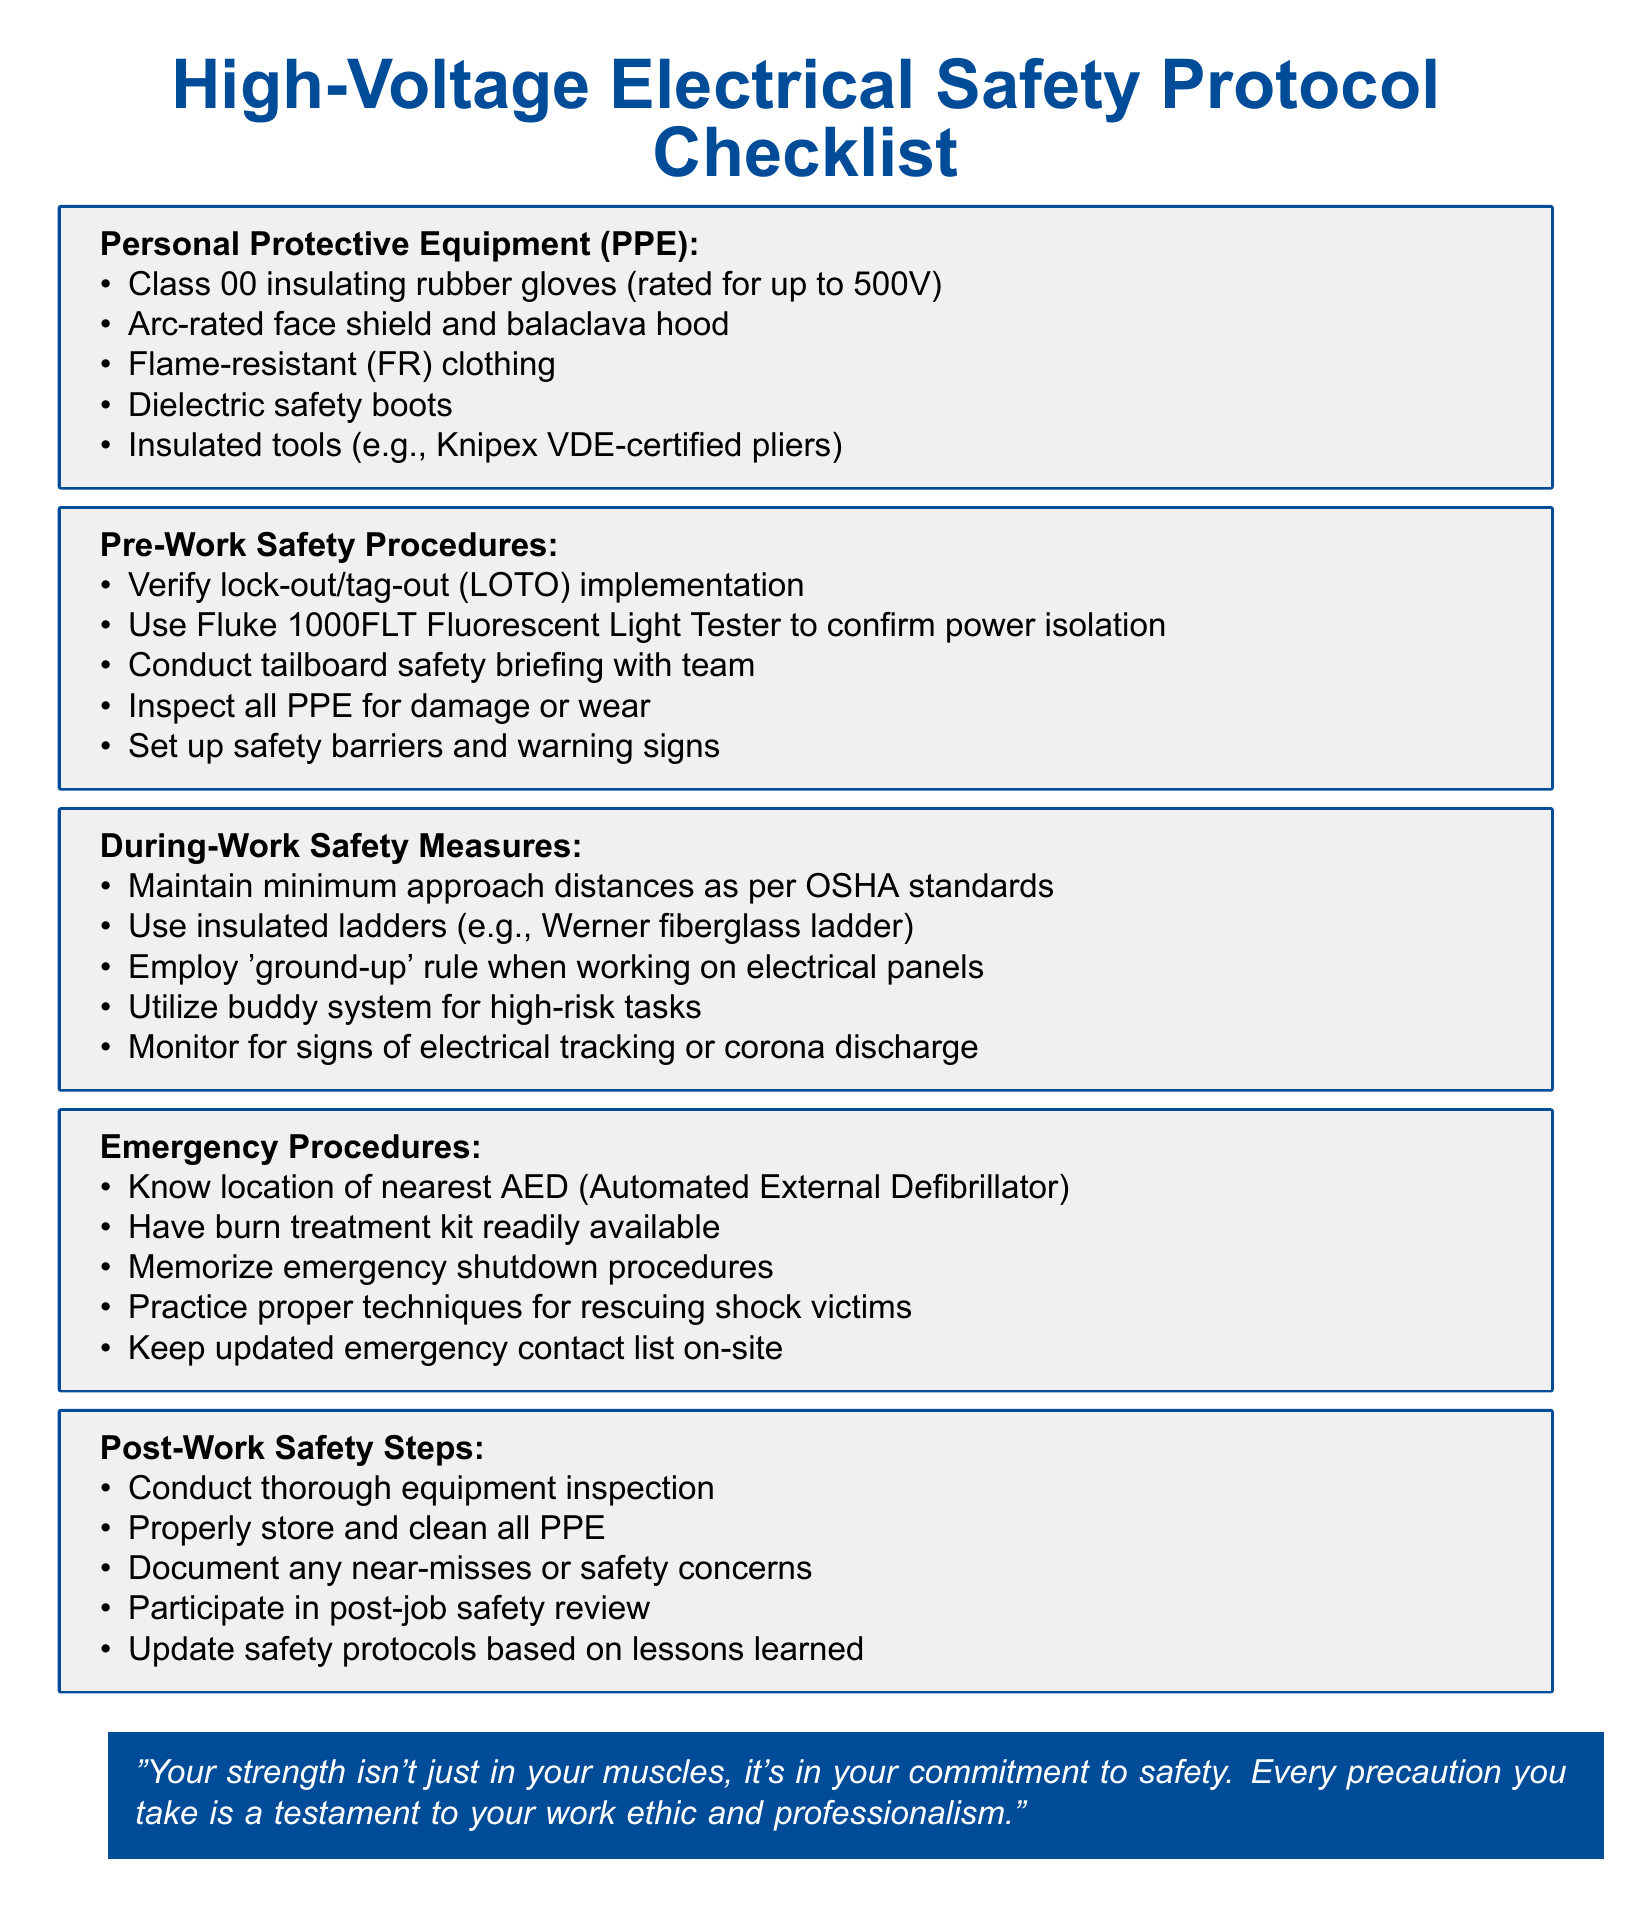What is the title of the checklist? The title of the checklist is specified at the beginning of the document.
Answer: High-Voltage Electrical Safety Protocol Checklist How many items are listed under Personal Protective Equipment (PPE)? The number of items in a specific section is clearly presented in the list format throughout the document.
Answer: 5 What type of gloves should be used? The specific type of gloves is mentioned in the PPE section for high-voltage safety.
Answer: Class 00 insulating rubber gloves What tools are recommended to confirm power isolation? The document explicitly states a specific tool for this purpose under pre-work safety procedures.
Answer: Fluke 1000FLT Fluorescent Light Tester What is the minimum distance to maintain according to OSHA standards? The minimum approach distance requirement is mentioned in the during-work safety measures.
Answer: Minimum approach distances What should be available for burn treatment? The item is specifically listed under emergency procedures as essential for addressing certain injuries.
Answer: Burn treatment kit What system should be utilized for high-risk tasks? The recommendation is made under during-work safety measures for increased safety during specific tasks.
Answer: Buddy system What should be documented after a job? This action is mentioned as an essential step in the post-work safety steps section of the checklist.
Answer: Near-misses or safety concerns In what situation should you memorize emergency shutdown procedures? The context is provided under emergency procedures that highlight the importance of being prepared.
Answer: Emergency procedures 